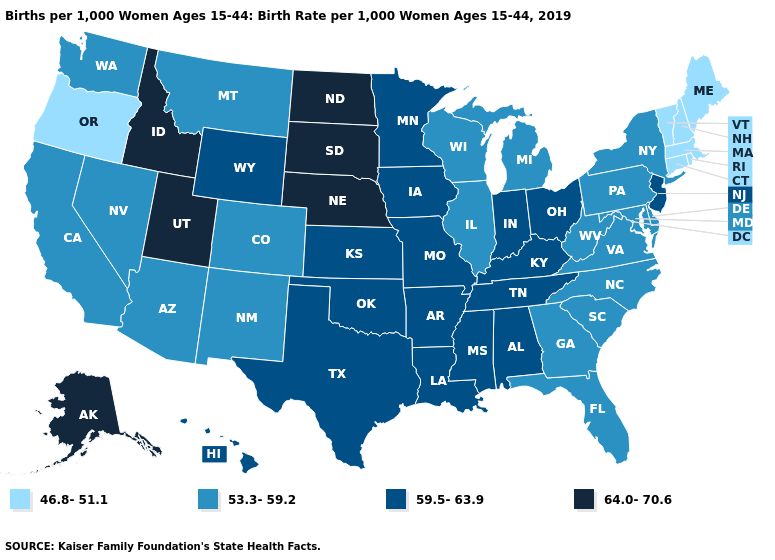Which states have the lowest value in the USA?
Short answer required. Connecticut, Maine, Massachusetts, New Hampshire, Oregon, Rhode Island, Vermont. Name the states that have a value in the range 53.3-59.2?
Quick response, please. Arizona, California, Colorado, Delaware, Florida, Georgia, Illinois, Maryland, Michigan, Montana, Nevada, New Mexico, New York, North Carolina, Pennsylvania, South Carolina, Virginia, Washington, West Virginia, Wisconsin. Name the states that have a value in the range 46.8-51.1?
Short answer required. Connecticut, Maine, Massachusetts, New Hampshire, Oregon, Rhode Island, Vermont. Name the states that have a value in the range 46.8-51.1?
Keep it brief. Connecticut, Maine, Massachusetts, New Hampshire, Oregon, Rhode Island, Vermont. How many symbols are there in the legend?
Give a very brief answer. 4. Name the states that have a value in the range 46.8-51.1?
Concise answer only. Connecticut, Maine, Massachusetts, New Hampshire, Oregon, Rhode Island, Vermont. What is the value of Ohio?
Keep it brief. 59.5-63.9. Does Michigan have the highest value in the USA?
Write a very short answer. No. Name the states that have a value in the range 53.3-59.2?
Write a very short answer. Arizona, California, Colorado, Delaware, Florida, Georgia, Illinois, Maryland, Michigan, Montana, Nevada, New Mexico, New York, North Carolina, Pennsylvania, South Carolina, Virginia, Washington, West Virginia, Wisconsin. What is the value of Louisiana?
Concise answer only. 59.5-63.9. Which states have the lowest value in the USA?
Concise answer only. Connecticut, Maine, Massachusetts, New Hampshire, Oregon, Rhode Island, Vermont. What is the lowest value in the Northeast?
Write a very short answer. 46.8-51.1. Does the first symbol in the legend represent the smallest category?
Quick response, please. Yes. Name the states that have a value in the range 53.3-59.2?
Short answer required. Arizona, California, Colorado, Delaware, Florida, Georgia, Illinois, Maryland, Michigan, Montana, Nevada, New Mexico, New York, North Carolina, Pennsylvania, South Carolina, Virginia, Washington, West Virginia, Wisconsin. Does New York have the lowest value in the USA?
Answer briefly. No. 